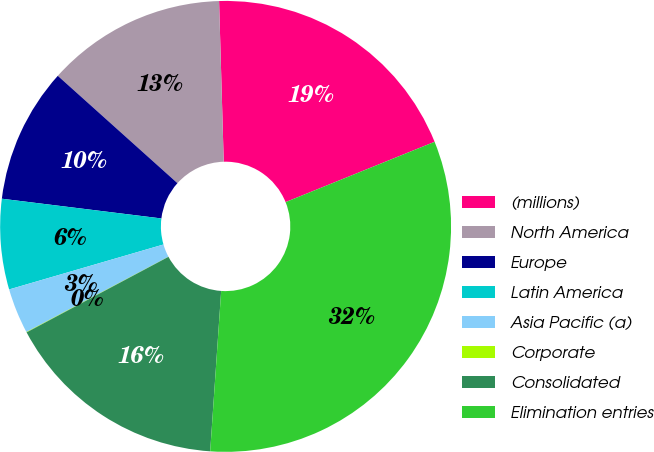Convert chart to OTSL. <chart><loc_0><loc_0><loc_500><loc_500><pie_chart><fcel>(millions)<fcel>North America<fcel>Europe<fcel>Latin America<fcel>Asia Pacific (a)<fcel>Corporate<fcel>Consolidated<fcel>Elimination entries<nl><fcel>19.34%<fcel>12.9%<fcel>9.68%<fcel>6.47%<fcel>3.25%<fcel>0.03%<fcel>16.12%<fcel>32.21%<nl></chart> 